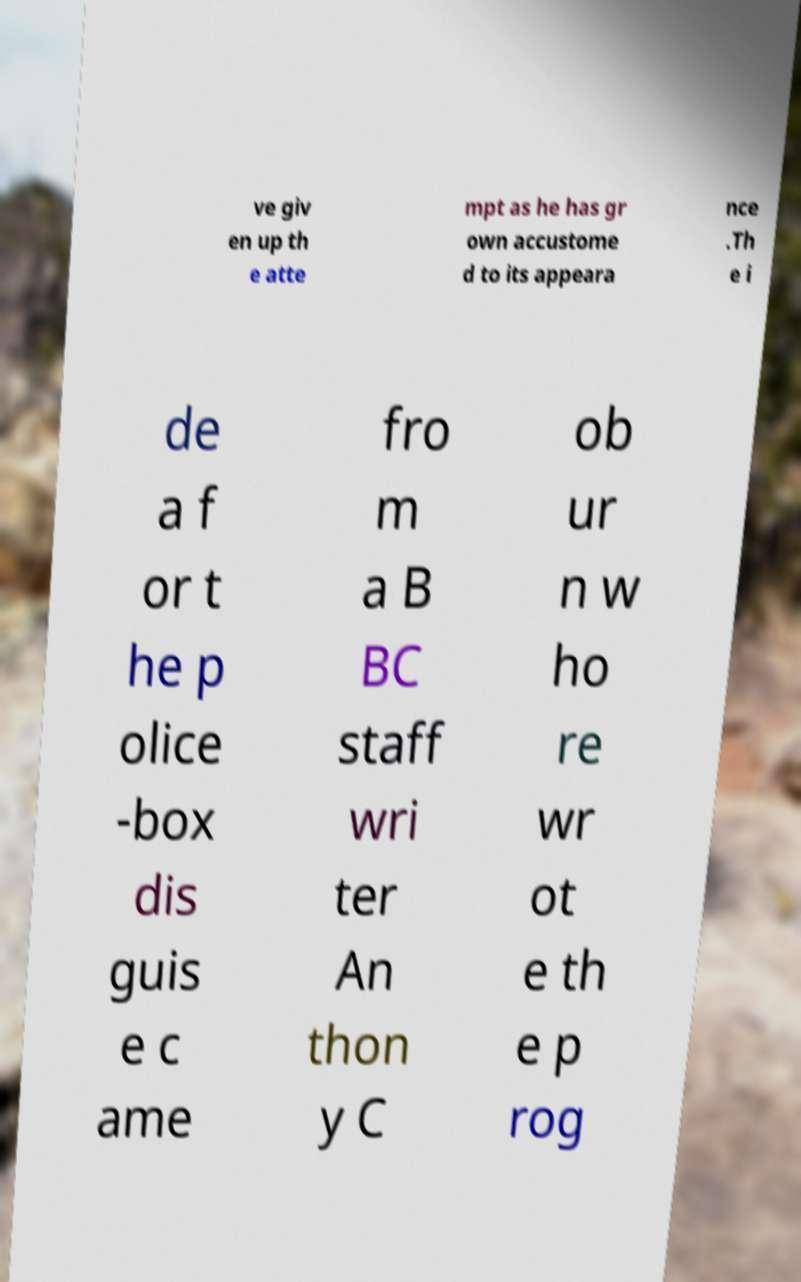Could you assist in decoding the text presented in this image and type it out clearly? ve giv en up th e atte mpt as he has gr own accustome d to its appeara nce .Th e i de a f or t he p olice -box dis guis e c ame fro m a B BC staff wri ter An thon y C ob ur n w ho re wr ot e th e p rog 